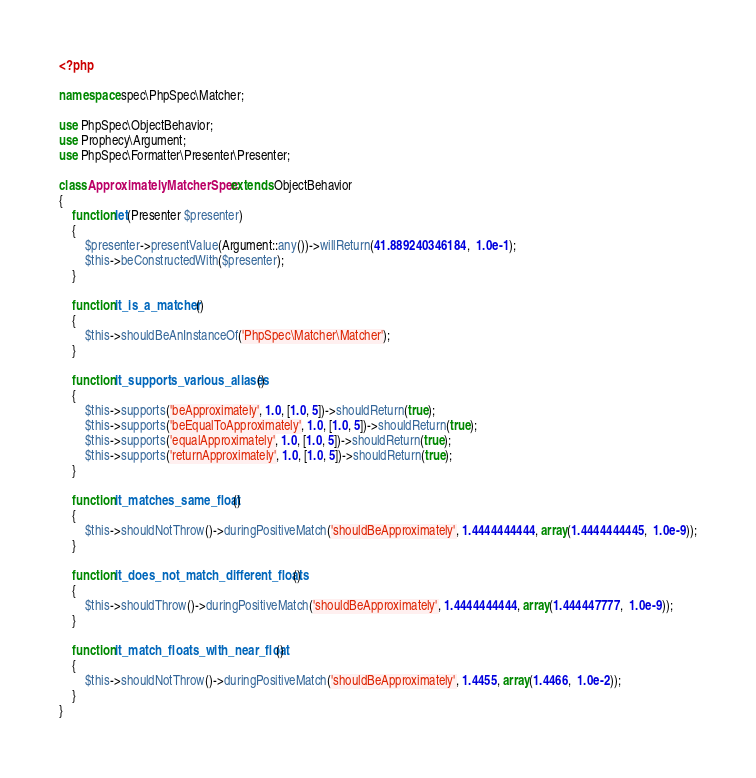Convert code to text. <code><loc_0><loc_0><loc_500><loc_500><_PHP_><?php

namespace spec\PhpSpec\Matcher;

use PhpSpec\ObjectBehavior;
use Prophecy\Argument;
use PhpSpec\Formatter\Presenter\Presenter;

class ApproximatelyMatcherSpec extends ObjectBehavior
{
    function let(Presenter $presenter)
    {
        $presenter->presentValue(Argument::any())->willReturn(41.889240346184,  1.0e-1);
        $this->beConstructedWith($presenter);
    }

    function it_is_a_matcher()
    {
        $this->shouldBeAnInstanceOf('PhpSpec\Matcher\Matcher');
    }

    function it_supports_various_aliases()
    {
        $this->supports('beApproximately', 1.0, [1.0, 5])->shouldReturn(true);
        $this->supports('beEqualToApproximately', 1.0, [1.0, 5])->shouldReturn(true);
        $this->supports('equalApproximately', 1.0, [1.0, 5])->shouldReturn(true);
        $this->supports('returnApproximately', 1.0, [1.0, 5])->shouldReturn(true);
    }

    function it_matches_same_float()
    {
        $this->shouldNotThrow()->duringPositiveMatch('shouldBeApproximately', 1.4444444444, array(1.4444444445,  1.0e-9));
    }

    function it_does_not_match_different_floats()
    {
        $this->shouldThrow()->duringPositiveMatch('shouldBeApproximately', 1.4444444444, array(1.444447777,  1.0e-9));
    }

    function it_match_floats_with_near_float()
    {
        $this->shouldNotThrow()->duringPositiveMatch('shouldBeApproximately', 1.4455, array(1.4466,  1.0e-2));
    }
}
</code> 